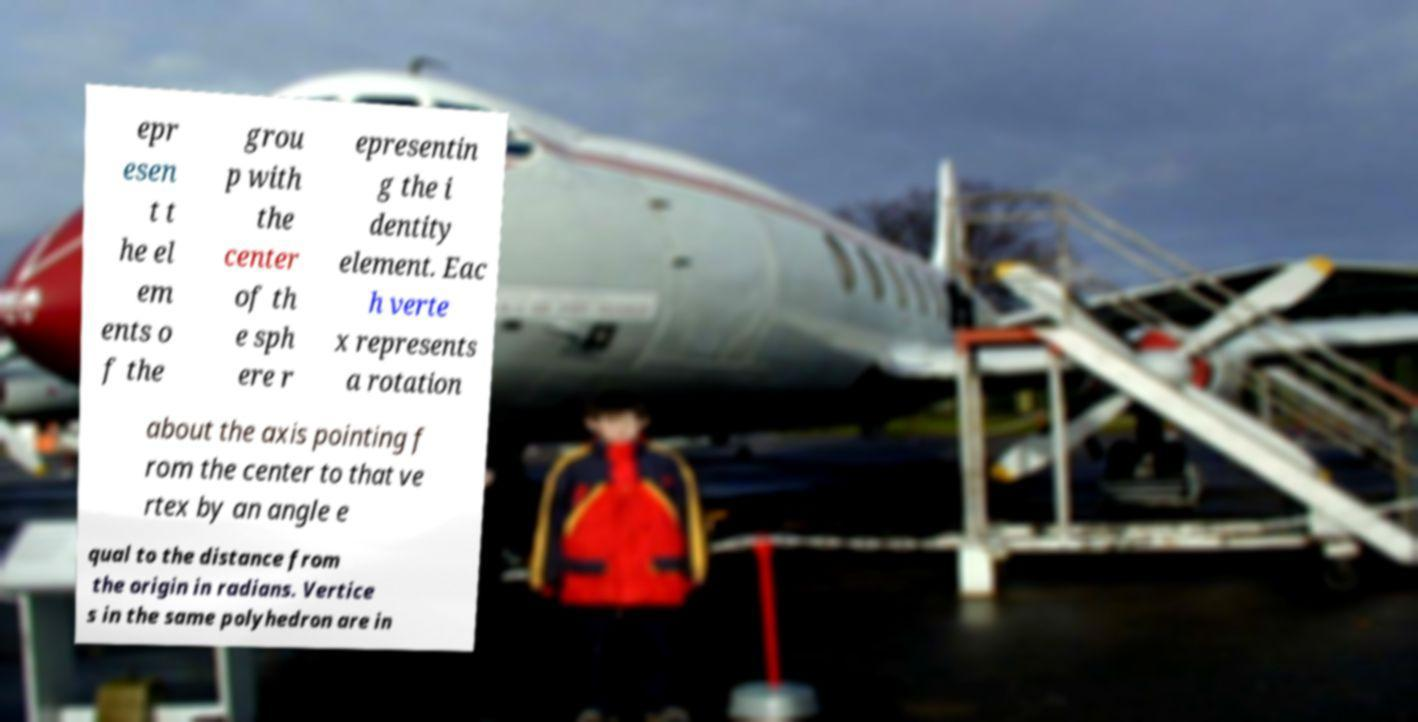Can you read and provide the text displayed in the image?This photo seems to have some interesting text. Can you extract and type it out for me? epr esen t t he el em ents o f the grou p with the center of th e sph ere r epresentin g the i dentity element. Eac h verte x represents a rotation about the axis pointing f rom the center to that ve rtex by an angle e qual to the distance from the origin in radians. Vertice s in the same polyhedron are in 